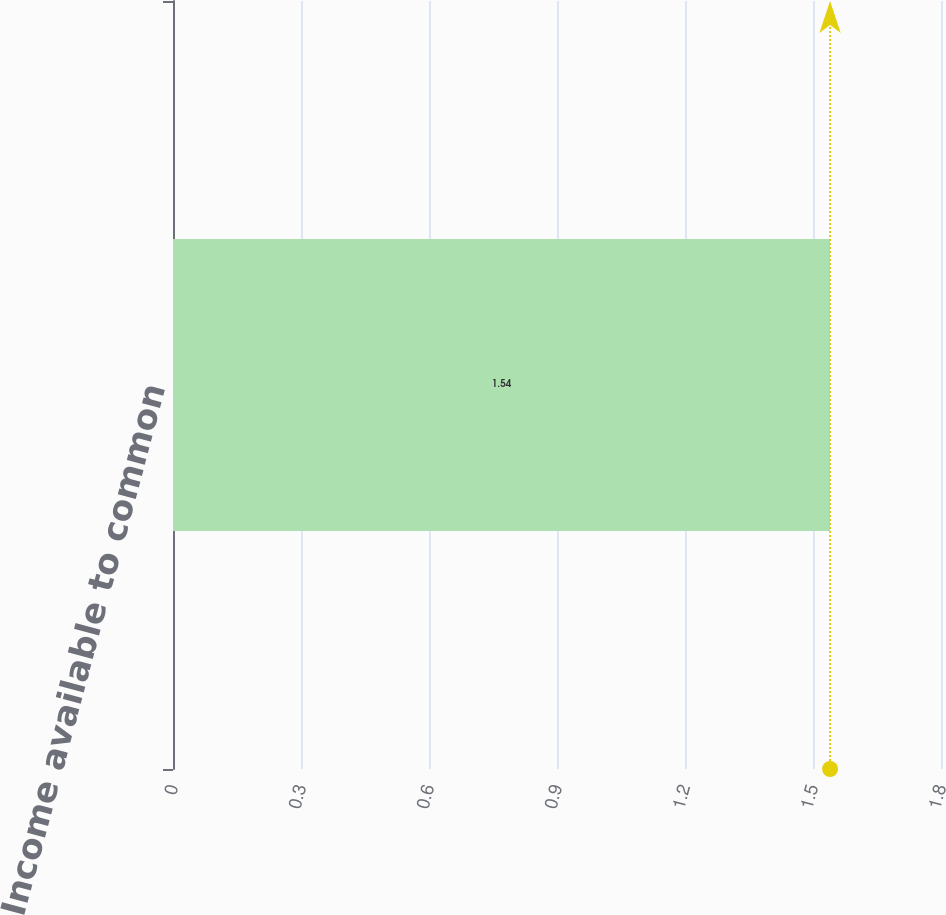Convert chart. <chart><loc_0><loc_0><loc_500><loc_500><bar_chart><fcel>Income available to common<nl><fcel>1.54<nl></chart> 